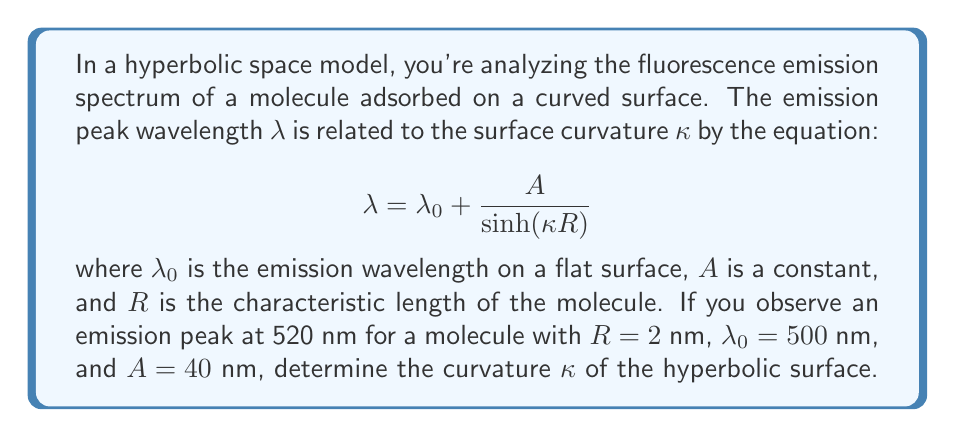Can you answer this question? To solve this problem, we'll follow these steps:

1) First, let's rearrange the given equation to isolate the term with κ:

   $$ \sinh(\kappa R) = \frac{A}{\lambda - \lambda_0} $$

2) Now, let's substitute the known values:
   λ = 520 nm
   λ₀ = 500 nm
   A = 40 nm
   R = 2 nm

   $$ \sinh(\kappa \cdot 2) = \frac{40}{520 - 500} = 2 $$

3) We can simplify this to:

   $$ \sinh(2\kappa) = 2 $$

4) To solve for κ, we need to apply the inverse hyperbolic sine (arcsinh) to both sides:

   $$ 2\kappa = \arcsinh(2) $$

5) Divide both sides by 2:

   $$ \kappa = \frac{\arcsinh(2)}{2} $$

6) Using a calculator or computer, we can evaluate arcsinh(2):

   $$ \kappa \approx \frac{1.4436}{2} \approx 0.7218 \text{ nm}^{-1} $$

Thus, the curvature of the hyperbolic surface is approximately 0.7218 nm⁻¹.
Answer: $\kappa \approx 0.7218 \text{ nm}^{-1}$ 